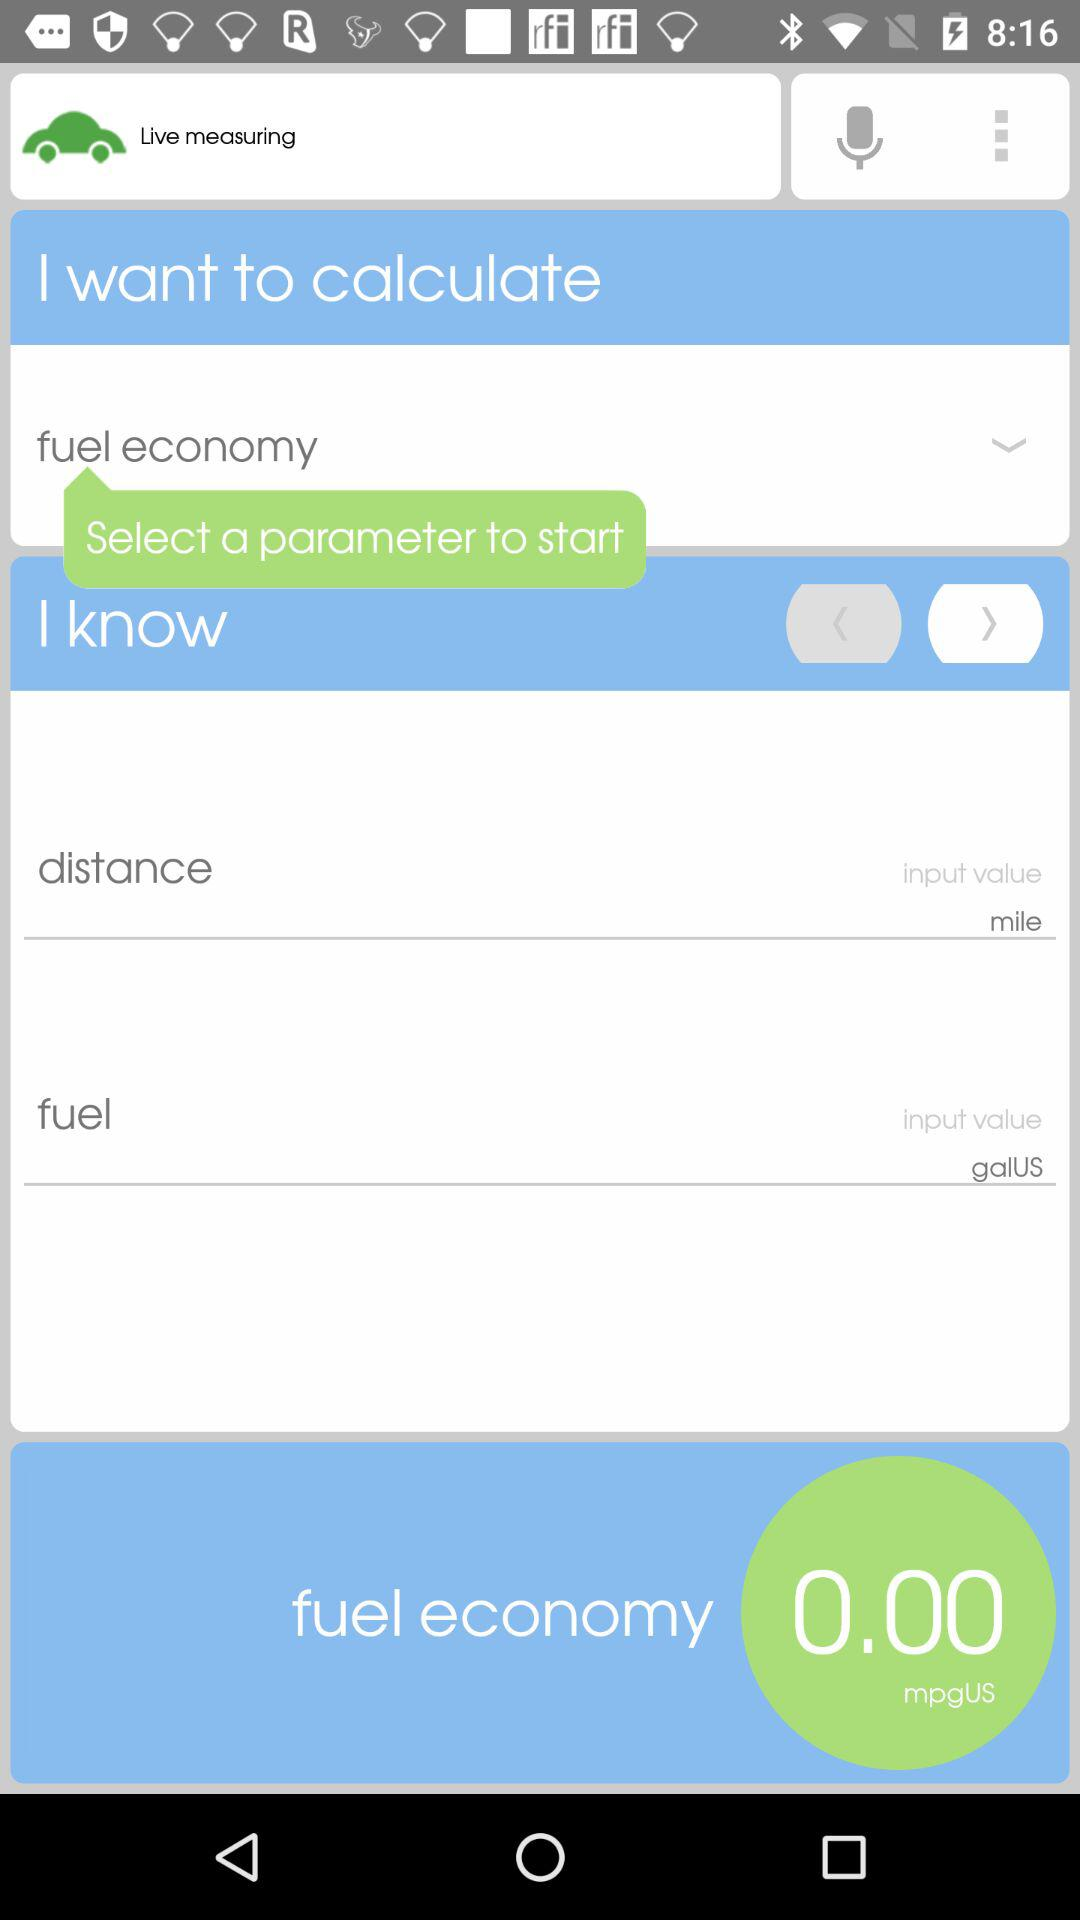Which option is selected with the input value "mile"? The selected option with the input value "mile" is "distance". 